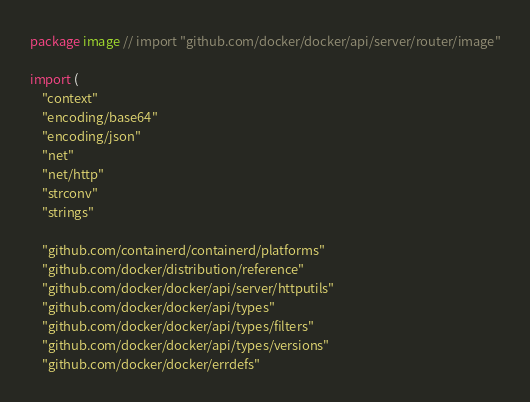Convert code to text. <code><loc_0><loc_0><loc_500><loc_500><_Go_>package image // import "github.com/docker/docker/api/server/router/image"

import (
	"context"
	"encoding/base64"
	"encoding/json"
	"net"
	"net/http"
	"strconv"
	"strings"

	"github.com/containerd/containerd/platforms"
	"github.com/docker/distribution/reference"
	"github.com/docker/docker/api/server/httputils"
	"github.com/docker/docker/api/types"
	"github.com/docker/docker/api/types/filters"
	"github.com/docker/docker/api/types/versions"
	"github.com/docker/docker/errdefs"</code> 